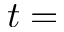<formula> <loc_0><loc_0><loc_500><loc_500>t =</formula> 